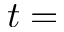<formula> <loc_0><loc_0><loc_500><loc_500>t =</formula> 